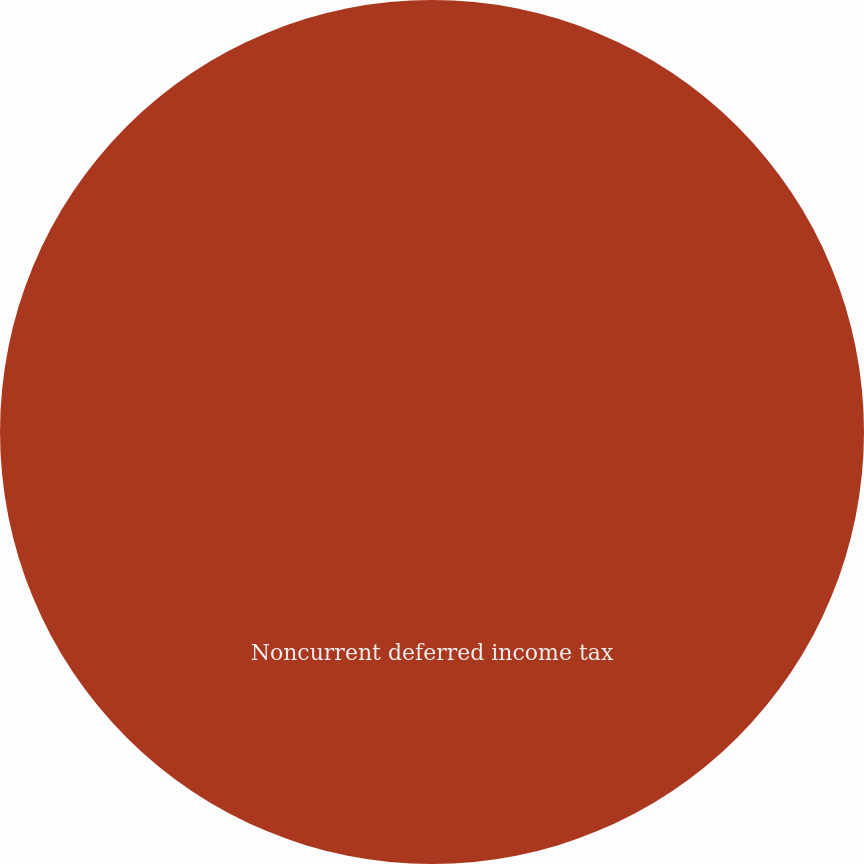Convert chart to OTSL. <chart><loc_0><loc_0><loc_500><loc_500><pie_chart><fcel>Noncurrent deferred income tax<nl><fcel>100.0%<nl></chart> 